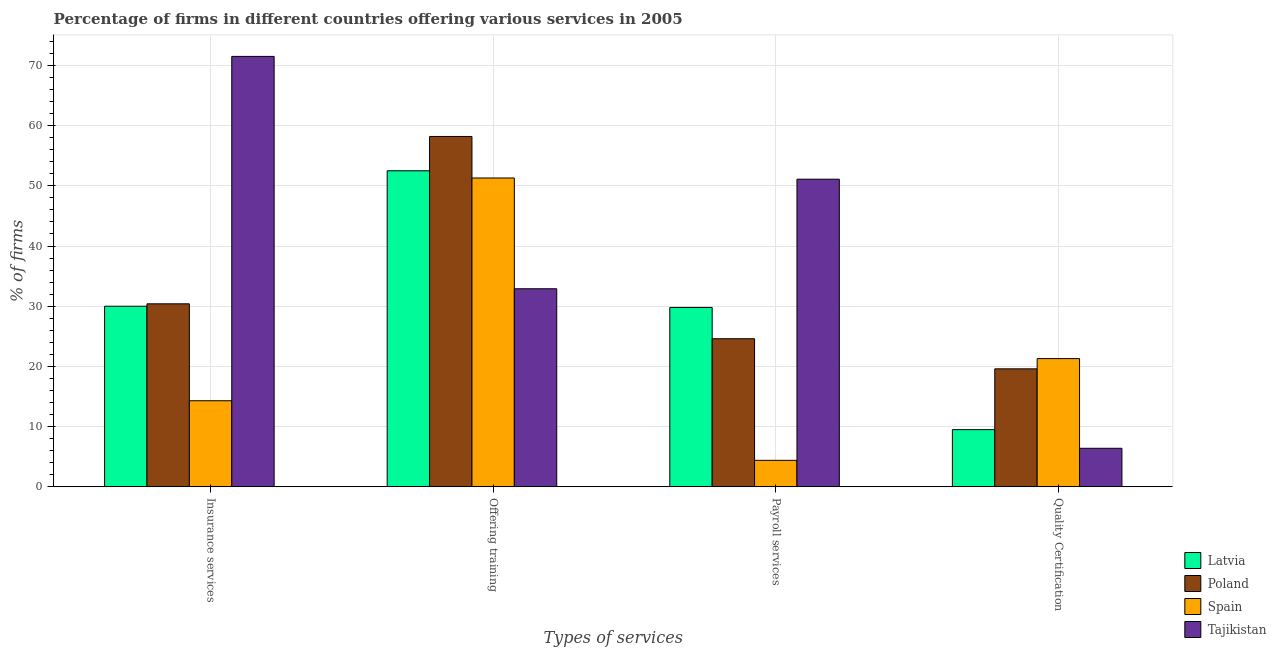How many different coloured bars are there?
Make the answer very short. 4. How many groups of bars are there?
Ensure brevity in your answer.  4. Are the number of bars per tick equal to the number of legend labels?
Offer a terse response. Yes. What is the label of the 3rd group of bars from the left?
Keep it short and to the point. Payroll services. Across all countries, what is the maximum percentage of firms offering training?
Your answer should be very brief. 58.2. In which country was the percentage of firms offering payroll services maximum?
Your response must be concise. Tajikistan. In which country was the percentage of firms offering insurance services minimum?
Provide a short and direct response. Spain. What is the total percentage of firms offering insurance services in the graph?
Offer a terse response. 146.2. What is the difference between the percentage of firms offering training in Poland and that in Tajikistan?
Keep it short and to the point. 25.3. What is the difference between the percentage of firms offering training in Latvia and the percentage of firms offering quality certification in Spain?
Give a very brief answer. 31.2. What is the average percentage of firms offering insurance services per country?
Your answer should be compact. 36.55. What is the difference between the percentage of firms offering insurance services and percentage of firms offering quality certification in Spain?
Give a very brief answer. -7. What is the ratio of the percentage of firms offering quality certification in Latvia to that in Tajikistan?
Your answer should be very brief. 1.48. Is the percentage of firms offering quality certification in Tajikistan less than that in Latvia?
Make the answer very short. Yes. Is the difference between the percentage of firms offering insurance services in Poland and Tajikistan greater than the difference between the percentage of firms offering quality certification in Poland and Tajikistan?
Your answer should be compact. No. What is the difference between the highest and the second highest percentage of firms offering insurance services?
Give a very brief answer. 41.1. What does the 4th bar from the left in Insurance services represents?
Your answer should be compact. Tajikistan. What does the 4th bar from the right in Quality Certification represents?
Keep it short and to the point. Latvia. How many countries are there in the graph?
Make the answer very short. 4. Are the values on the major ticks of Y-axis written in scientific E-notation?
Offer a terse response. No. Does the graph contain any zero values?
Keep it short and to the point. No. Does the graph contain grids?
Provide a succinct answer. Yes. How many legend labels are there?
Your answer should be very brief. 4. How are the legend labels stacked?
Make the answer very short. Vertical. What is the title of the graph?
Offer a very short reply. Percentage of firms in different countries offering various services in 2005. What is the label or title of the X-axis?
Offer a very short reply. Types of services. What is the label or title of the Y-axis?
Give a very brief answer. % of firms. What is the % of firms in Latvia in Insurance services?
Provide a short and direct response. 30. What is the % of firms of Poland in Insurance services?
Offer a terse response. 30.4. What is the % of firms in Tajikistan in Insurance services?
Offer a very short reply. 71.5. What is the % of firms of Latvia in Offering training?
Give a very brief answer. 52.5. What is the % of firms in Poland in Offering training?
Make the answer very short. 58.2. What is the % of firms of Spain in Offering training?
Provide a succinct answer. 51.3. What is the % of firms in Tajikistan in Offering training?
Provide a succinct answer. 32.9. What is the % of firms of Latvia in Payroll services?
Offer a very short reply. 29.8. What is the % of firms of Poland in Payroll services?
Provide a succinct answer. 24.6. What is the % of firms in Tajikistan in Payroll services?
Offer a terse response. 51.1. What is the % of firms in Latvia in Quality Certification?
Give a very brief answer. 9.5. What is the % of firms in Poland in Quality Certification?
Your answer should be compact. 19.6. What is the % of firms of Spain in Quality Certification?
Your answer should be very brief. 21.3. What is the % of firms of Tajikistan in Quality Certification?
Make the answer very short. 6.4. Across all Types of services, what is the maximum % of firms in Latvia?
Your answer should be compact. 52.5. Across all Types of services, what is the maximum % of firms of Poland?
Your response must be concise. 58.2. Across all Types of services, what is the maximum % of firms of Spain?
Provide a short and direct response. 51.3. Across all Types of services, what is the maximum % of firms of Tajikistan?
Provide a short and direct response. 71.5. Across all Types of services, what is the minimum % of firms in Latvia?
Offer a very short reply. 9.5. Across all Types of services, what is the minimum % of firms of Poland?
Offer a terse response. 19.6. Across all Types of services, what is the minimum % of firms in Spain?
Your response must be concise. 4.4. What is the total % of firms in Latvia in the graph?
Your answer should be compact. 121.8. What is the total % of firms of Poland in the graph?
Ensure brevity in your answer.  132.8. What is the total % of firms in Spain in the graph?
Give a very brief answer. 91.3. What is the total % of firms in Tajikistan in the graph?
Your answer should be compact. 161.9. What is the difference between the % of firms in Latvia in Insurance services and that in Offering training?
Provide a succinct answer. -22.5. What is the difference between the % of firms of Poland in Insurance services and that in Offering training?
Your answer should be very brief. -27.8. What is the difference between the % of firms in Spain in Insurance services and that in Offering training?
Make the answer very short. -37. What is the difference between the % of firms in Tajikistan in Insurance services and that in Offering training?
Offer a terse response. 38.6. What is the difference between the % of firms in Latvia in Insurance services and that in Payroll services?
Provide a short and direct response. 0.2. What is the difference between the % of firms of Spain in Insurance services and that in Payroll services?
Make the answer very short. 9.9. What is the difference between the % of firms of Tajikistan in Insurance services and that in Payroll services?
Give a very brief answer. 20.4. What is the difference between the % of firms of Latvia in Insurance services and that in Quality Certification?
Your answer should be compact. 20.5. What is the difference between the % of firms in Poland in Insurance services and that in Quality Certification?
Offer a very short reply. 10.8. What is the difference between the % of firms of Tajikistan in Insurance services and that in Quality Certification?
Offer a very short reply. 65.1. What is the difference between the % of firms of Latvia in Offering training and that in Payroll services?
Ensure brevity in your answer.  22.7. What is the difference between the % of firms in Poland in Offering training and that in Payroll services?
Your response must be concise. 33.6. What is the difference between the % of firms of Spain in Offering training and that in Payroll services?
Provide a succinct answer. 46.9. What is the difference between the % of firms in Tajikistan in Offering training and that in Payroll services?
Provide a short and direct response. -18.2. What is the difference between the % of firms in Poland in Offering training and that in Quality Certification?
Make the answer very short. 38.6. What is the difference between the % of firms in Spain in Offering training and that in Quality Certification?
Your answer should be very brief. 30. What is the difference between the % of firms in Tajikistan in Offering training and that in Quality Certification?
Ensure brevity in your answer.  26.5. What is the difference between the % of firms in Latvia in Payroll services and that in Quality Certification?
Offer a terse response. 20.3. What is the difference between the % of firms of Poland in Payroll services and that in Quality Certification?
Offer a terse response. 5. What is the difference between the % of firms in Spain in Payroll services and that in Quality Certification?
Give a very brief answer. -16.9. What is the difference between the % of firms of Tajikistan in Payroll services and that in Quality Certification?
Keep it short and to the point. 44.7. What is the difference between the % of firms in Latvia in Insurance services and the % of firms in Poland in Offering training?
Your answer should be compact. -28.2. What is the difference between the % of firms in Latvia in Insurance services and the % of firms in Spain in Offering training?
Your answer should be compact. -21.3. What is the difference between the % of firms of Poland in Insurance services and the % of firms of Spain in Offering training?
Offer a terse response. -20.9. What is the difference between the % of firms in Poland in Insurance services and the % of firms in Tajikistan in Offering training?
Your answer should be very brief. -2.5. What is the difference between the % of firms of Spain in Insurance services and the % of firms of Tajikistan in Offering training?
Provide a succinct answer. -18.6. What is the difference between the % of firms in Latvia in Insurance services and the % of firms in Spain in Payroll services?
Keep it short and to the point. 25.6. What is the difference between the % of firms in Latvia in Insurance services and the % of firms in Tajikistan in Payroll services?
Your answer should be very brief. -21.1. What is the difference between the % of firms in Poland in Insurance services and the % of firms in Spain in Payroll services?
Offer a very short reply. 26. What is the difference between the % of firms in Poland in Insurance services and the % of firms in Tajikistan in Payroll services?
Provide a short and direct response. -20.7. What is the difference between the % of firms in Spain in Insurance services and the % of firms in Tajikistan in Payroll services?
Ensure brevity in your answer.  -36.8. What is the difference between the % of firms of Latvia in Insurance services and the % of firms of Poland in Quality Certification?
Provide a succinct answer. 10.4. What is the difference between the % of firms in Latvia in Insurance services and the % of firms in Spain in Quality Certification?
Give a very brief answer. 8.7. What is the difference between the % of firms of Latvia in Insurance services and the % of firms of Tajikistan in Quality Certification?
Your answer should be compact. 23.6. What is the difference between the % of firms of Latvia in Offering training and the % of firms of Poland in Payroll services?
Give a very brief answer. 27.9. What is the difference between the % of firms in Latvia in Offering training and the % of firms in Spain in Payroll services?
Keep it short and to the point. 48.1. What is the difference between the % of firms of Latvia in Offering training and the % of firms of Tajikistan in Payroll services?
Provide a succinct answer. 1.4. What is the difference between the % of firms of Poland in Offering training and the % of firms of Spain in Payroll services?
Offer a very short reply. 53.8. What is the difference between the % of firms of Poland in Offering training and the % of firms of Tajikistan in Payroll services?
Offer a very short reply. 7.1. What is the difference between the % of firms of Latvia in Offering training and the % of firms of Poland in Quality Certification?
Ensure brevity in your answer.  32.9. What is the difference between the % of firms of Latvia in Offering training and the % of firms of Spain in Quality Certification?
Keep it short and to the point. 31.2. What is the difference between the % of firms in Latvia in Offering training and the % of firms in Tajikistan in Quality Certification?
Offer a terse response. 46.1. What is the difference between the % of firms in Poland in Offering training and the % of firms in Spain in Quality Certification?
Your answer should be very brief. 36.9. What is the difference between the % of firms of Poland in Offering training and the % of firms of Tajikistan in Quality Certification?
Offer a very short reply. 51.8. What is the difference between the % of firms of Spain in Offering training and the % of firms of Tajikistan in Quality Certification?
Make the answer very short. 44.9. What is the difference between the % of firms of Latvia in Payroll services and the % of firms of Poland in Quality Certification?
Make the answer very short. 10.2. What is the difference between the % of firms of Latvia in Payroll services and the % of firms of Tajikistan in Quality Certification?
Offer a very short reply. 23.4. What is the difference between the % of firms in Poland in Payroll services and the % of firms in Spain in Quality Certification?
Offer a very short reply. 3.3. What is the difference between the % of firms of Poland in Payroll services and the % of firms of Tajikistan in Quality Certification?
Your answer should be very brief. 18.2. What is the difference between the % of firms of Spain in Payroll services and the % of firms of Tajikistan in Quality Certification?
Keep it short and to the point. -2. What is the average % of firms in Latvia per Types of services?
Give a very brief answer. 30.45. What is the average % of firms of Poland per Types of services?
Provide a succinct answer. 33.2. What is the average % of firms in Spain per Types of services?
Provide a succinct answer. 22.82. What is the average % of firms in Tajikistan per Types of services?
Keep it short and to the point. 40.48. What is the difference between the % of firms of Latvia and % of firms of Spain in Insurance services?
Ensure brevity in your answer.  15.7. What is the difference between the % of firms of Latvia and % of firms of Tajikistan in Insurance services?
Provide a succinct answer. -41.5. What is the difference between the % of firms of Poland and % of firms of Spain in Insurance services?
Your response must be concise. 16.1. What is the difference between the % of firms in Poland and % of firms in Tajikistan in Insurance services?
Ensure brevity in your answer.  -41.1. What is the difference between the % of firms in Spain and % of firms in Tajikistan in Insurance services?
Provide a short and direct response. -57.2. What is the difference between the % of firms in Latvia and % of firms in Spain in Offering training?
Give a very brief answer. 1.2. What is the difference between the % of firms in Latvia and % of firms in Tajikistan in Offering training?
Keep it short and to the point. 19.6. What is the difference between the % of firms of Poland and % of firms of Spain in Offering training?
Your answer should be compact. 6.9. What is the difference between the % of firms in Poland and % of firms in Tajikistan in Offering training?
Your answer should be compact. 25.3. What is the difference between the % of firms in Spain and % of firms in Tajikistan in Offering training?
Give a very brief answer. 18.4. What is the difference between the % of firms in Latvia and % of firms in Poland in Payroll services?
Provide a short and direct response. 5.2. What is the difference between the % of firms of Latvia and % of firms of Spain in Payroll services?
Offer a very short reply. 25.4. What is the difference between the % of firms of Latvia and % of firms of Tajikistan in Payroll services?
Offer a very short reply. -21.3. What is the difference between the % of firms in Poland and % of firms in Spain in Payroll services?
Give a very brief answer. 20.2. What is the difference between the % of firms of Poland and % of firms of Tajikistan in Payroll services?
Offer a very short reply. -26.5. What is the difference between the % of firms in Spain and % of firms in Tajikistan in Payroll services?
Offer a terse response. -46.7. What is the difference between the % of firms in Latvia and % of firms in Spain in Quality Certification?
Ensure brevity in your answer.  -11.8. What is the difference between the % of firms in Poland and % of firms in Spain in Quality Certification?
Make the answer very short. -1.7. What is the difference between the % of firms in Poland and % of firms in Tajikistan in Quality Certification?
Your response must be concise. 13.2. What is the ratio of the % of firms of Latvia in Insurance services to that in Offering training?
Offer a terse response. 0.57. What is the ratio of the % of firms in Poland in Insurance services to that in Offering training?
Your response must be concise. 0.52. What is the ratio of the % of firms of Spain in Insurance services to that in Offering training?
Your response must be concise. 0.28. What is the ratio of the % of firms in Tajikistan in Insurance services to that in Offering training?
Make the answer very short. 2.17. What is the ratio of the % of firms in Poland in Insurance services to that in Payroll services?
Provide a succinct answer. 1.24. What is the ratio of the % of firms of Spain in Insurance services to that in Payroll services?
Keep it short and to the point. 3.25. What is the ratio of the % of firms of Tajikistan in Insurance services to that in Payroll services?
Ensure brevity in your answer.  1.4. What is the ratio of the % of firms in Latvia in Insurance services to that in Quality Certification?
Give a very brief answer. 3.16. What is the ratio of the % of firms in Poland in Insurance services to that in Quality Certification?
Your answer should be very brief. 1.55. What is the ratio of the % of firms of Spain in Insurance services to that in Quality Certification?
Keep it short and to the point. 0.67. What is the ratio of the % of firms of Tajikistan in Insurance services to that in Quality Certification?
Offer a very short reply. 11.17. What is the ratio of the % of firms of Latvia in Offering training to that in Payroll services?
Offer a terse response. 1.76. What is the ratio of the % of firms of Poland in Offering training to that in Payroll services?
Offer a terse response. 2.37. What is the ratio of the % of firms in Spain in Offering training to that in Payroll services?
Give a very brief answer. 11.66. What is the ratio of the % of firms of Tajikistan in Offering training to that in Payroll services?
Offer a very short reply. 0.64. What is the ratio of the % of firms of Latvia in Offering training to that in Quality Certification?
Your answer should be compact. 5.53. What is the ratio of the % of firms in Poland in Offering training to that in Quality Certification?
Your answer should be compact. 2.97. What is the ratio of the % of firms in Spain in Offering training to that in Quality Certification?
Your answer should be very brief. 2.41. What is the ratio of the % of firms of Tajikistan in Offering training to that in Quality Certification?
Keep it short and to the point. 5.14. What is the ratio of the % of firms of Latvia in Payroll services to that in Quality Certification?
Give a very brief answer. 3.14. What is the ratio of the % of firms in Poland in Payroll services to that in Quality Certification?
Your answer should be very brief. 1.26. What is the ratio of the % of firms of Spain in Payroll services to that in Quality Certification?
Make the answer very short. 0.21. What is the ratio of the % of firms of Tajikistan in Payroll services to that in Quality Certification?
Your response must be concise. 7.98. What is the difference between the highest and the second highest % of firms in Poland?
Your answer should be compact. 27.8. What is the difference between the highest and the second highest % of firms in Spain?
Offer a very short reply. 30. What is the difference between the highest and the second highest % of firms of Tajikistan?
Offer a very short reply. 20.4. What is the difference between the highest and the lowest % of firms in Latvia?
Provide a short and direct response. 43. What is the difference between the highest and the lowest % of firms in Poland?
Offer a terse response. 38.6. What is the difference between the highest and the lowest % of firms in Spain?
Provide a short and direct response. 46.9. What is the difference between the highest and the lowest % of firms in Tajikistan?
Your answer should be very brief. 65.1. 